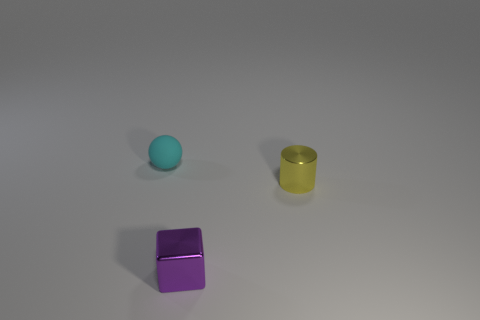Subtract all balls. How many objects are left? 2 Add 1 large purple metal cylinders. How many objects exist? 4 Add 1 small gray rubber balls. How many small gray rubber balls exist? 1 Subtract 0 blue cylinders. How many objects are left? 3 Subtract all green cubes. Subtract all yellow cylinders. How many cubes are left? 1 Subtract all yellow metal cylinders. Subtract all rubber objects. How many objects are left? 1 Add 3 tiny yellow metallic things. How many tiny yellow metallic things are left? 4 